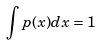<formula> <loc_0><loc_0><loc_500><loc_500>\int p ( x ) d x = 1</formula> 